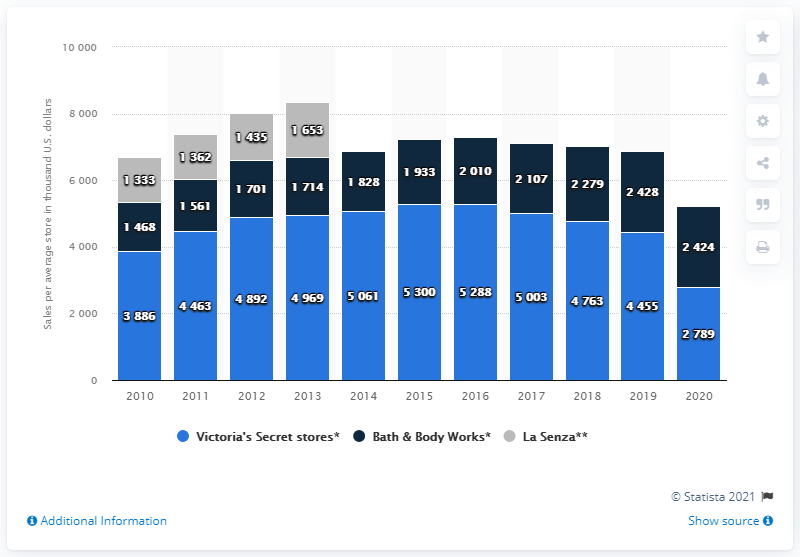Outline some significant characteristics in this image. In the United States in 2020, the average sales per Victoria's Secret store was approximately 2,789. 